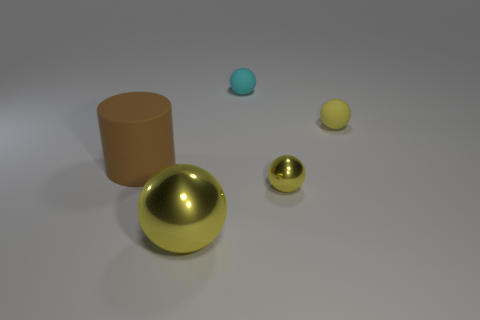Compared to the other objects, how does the lighting seem to affect the large brown cylinder? The large brown cylinder, being matte, doesn't reflect much light, giving it a softer appearance in contrast to the shiny gold sphere, which has bright highlights due to its reflective surface. 